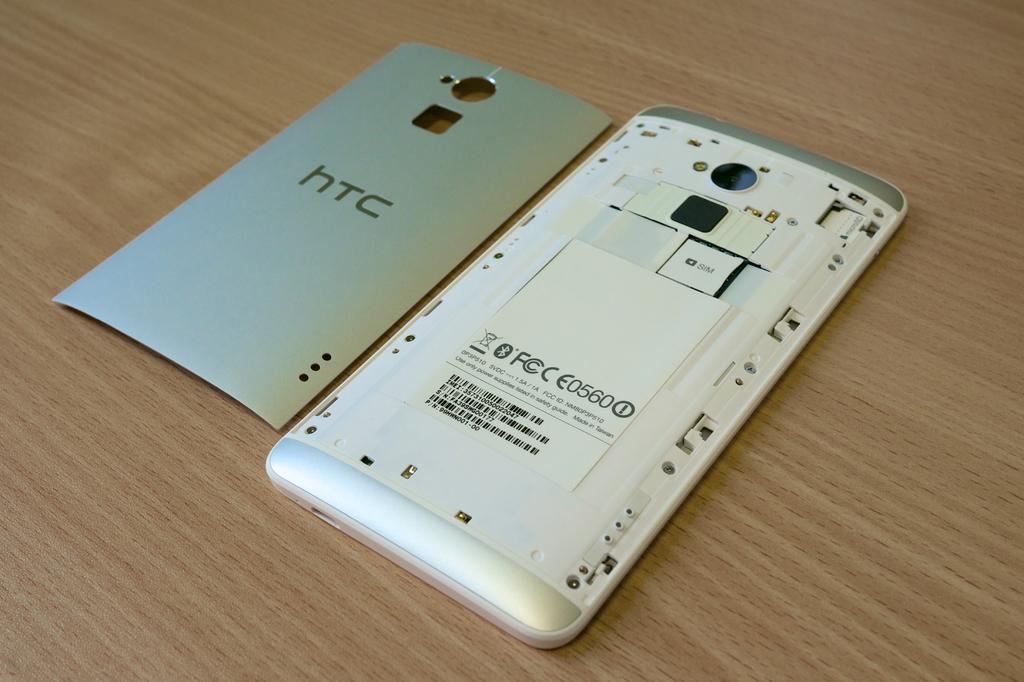What brand of phone is this?
Keep it short and to the point. Htc. 